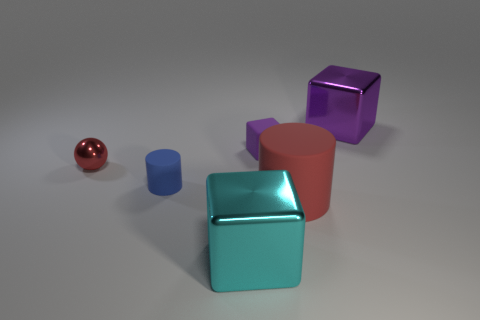What number of cubes are either big rubber objects or small red metal objects?
Keep it short and to the point. 0. There is a thing that is the same color as the tiny matte cube; what is its material?
Offer a very short reply. Metal. How many red metallic objects are the same shape as the red rubber object?
Your answer should be compact. 0. Is the number of cylinders left of the matte cube greater than the number of large cyan shiny blocks that are in front of the tiny blue matte cylinder?
Your response must be concise. No. Do the large metal block that is in front of the tiny shiny thing and the ball have the same color?
Your answer should be compact. No. The cyan block is what size?
Offer a very short reply. Large. There is a purple block that is the same size as the cyan thing; what is it made of?
Offer a very short reply. Metal. There is a large shiny block on the left side of the purple metallic object; what color is it?
Provide a succinct answer. Cyan. What number of green matte cylinders are there?
Provide a short and direct response. 0. There is a metallic block to the left of the shiny block right of the red rubber cylinder; are there any shiny spheres that are on the right side of it?
Ensure brevity in your answer.  No. 